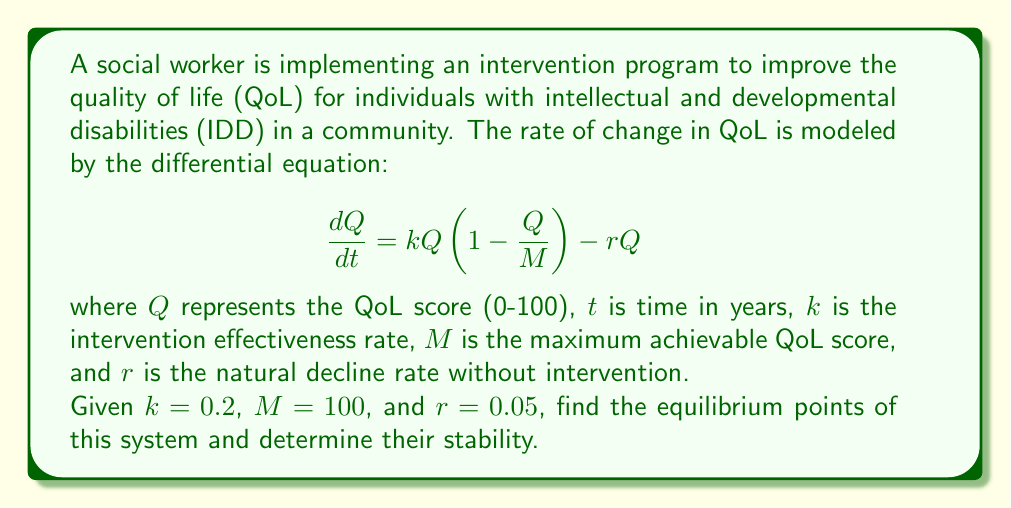Could you help me with this problem? To solve this problem, we'll follow these steps:

1) First, let's identify the equilibrium points. These occur when $\frac{dQ}{dt} = 0$.

2) Set up the equation:
   $$0 = kQ(1 - \frac{Q}{M}) - rQ$$

3) Substitute the given values:
   $$0 = 0.2Q(1 - \frac{Q}{100}) - 0.05Q$$

4) Simplify:
   $$0 = 0.2Q - 0.002Q^2 - 0.05Q$$
   $$0 = 0.15Q - 0.002Q^2$$

5) Factor out Q:
   $$0 = Q(0.15 - 0.002Q)$$

6) Solve for Q:
   Either $Q = 0$ or $0.15 - 0.002Q = 0$
   From the second equation: $Q = 75$

7) Therefore, the equilibrium points are $Q = 0$ and $Q = 75$.

8) To determine stability, we need to evaluate $\frac{d}{dQ}(\frac{dQ}{dt})$ at each equilibrium point:

   $$\frac{d}{dQ}(\frac{dQ}{dt}) = k(1 - \frac{2Q}{M}) - r$$

9) Substitute the values:
   $$\frac{d}{dQ}(\frac{dQ}{dt}) = 0.2(1 - \frac{2Q}{100}) - 0.05$$

10) Evaluate at $Q = 0$:
    $$0.2(1 - 0) - 0.05 = 0.15$$
    This is positive, so $Q = 0$ is an unstable equilibrium.

11) Evaluate at $Q = 75$:
    $$0.2(1 - \frac{2(75)}{100}) - 0.05 = -0.15$$
    This is negative, so $Q = 75$ is a stable equilibrium.
Answer: Equilibrium points: $Q = 0$ (unstable) and $Q = 75$ (stable) 